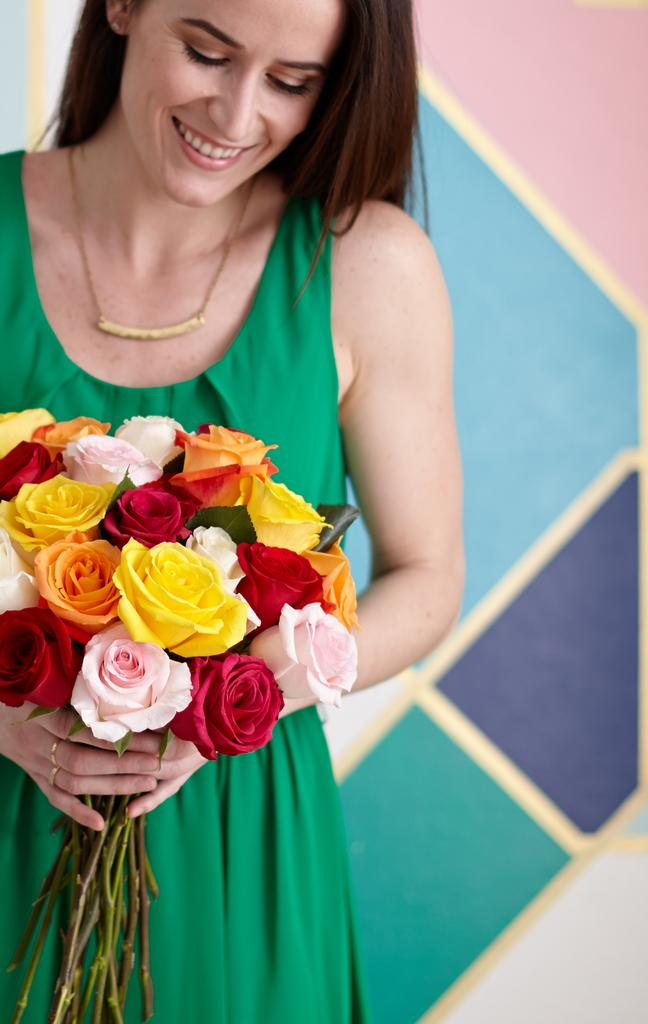Who is present in the image? There is a woman in the image. What is the woman holding? The woman is holding a bouquet. What can be seen behind the woman? There is a wall visible behind the woman. How many boats are visible in the image? There are no boats present in the image. What type of ducks can be seen swimming in the water in the image? There is no water or ducks present in the image. 